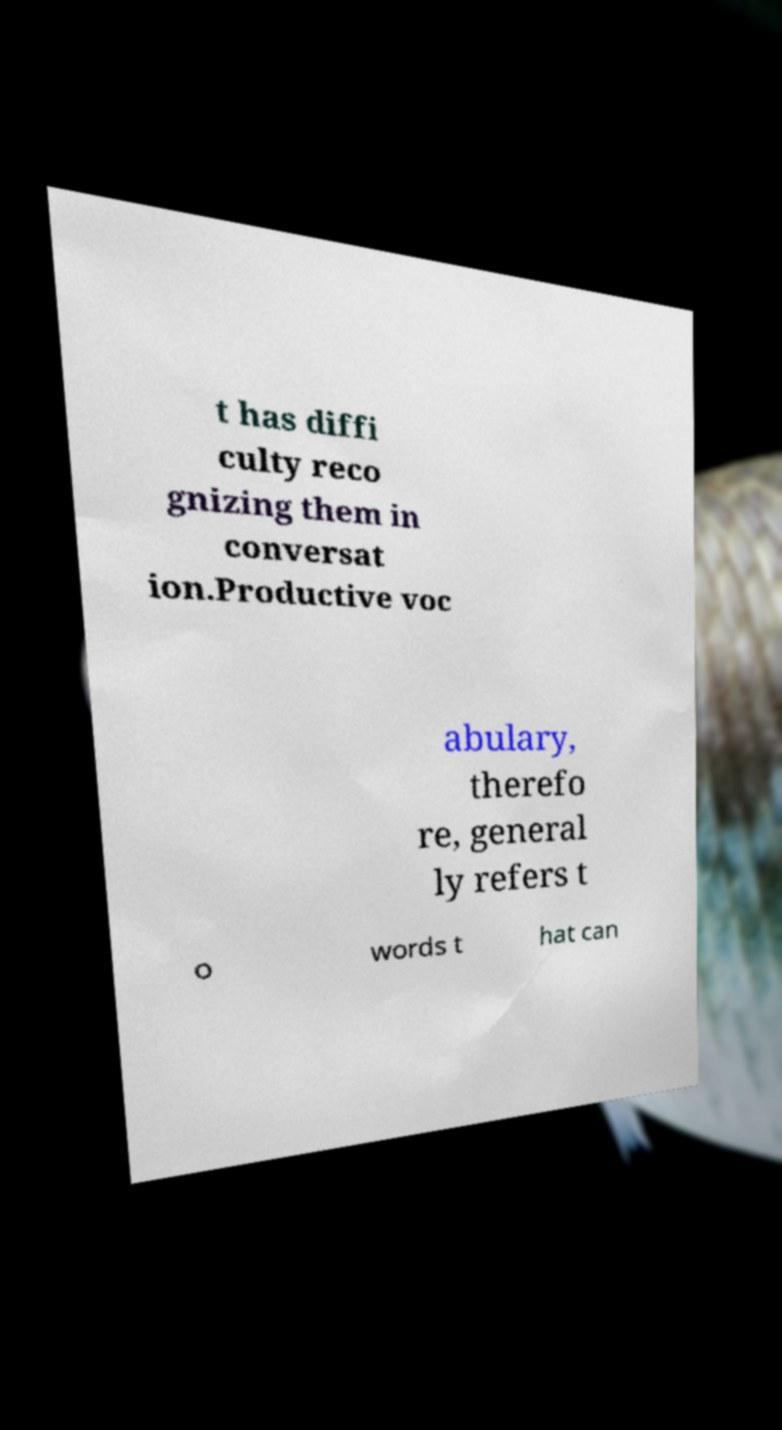There's text embedded in this image that I need extracted. Can you transcribe it verbatim? t has diffi culty reco gnizing them in conversat ion.Productive voc abulary, therefo re, general ly refers t o words t hat can 